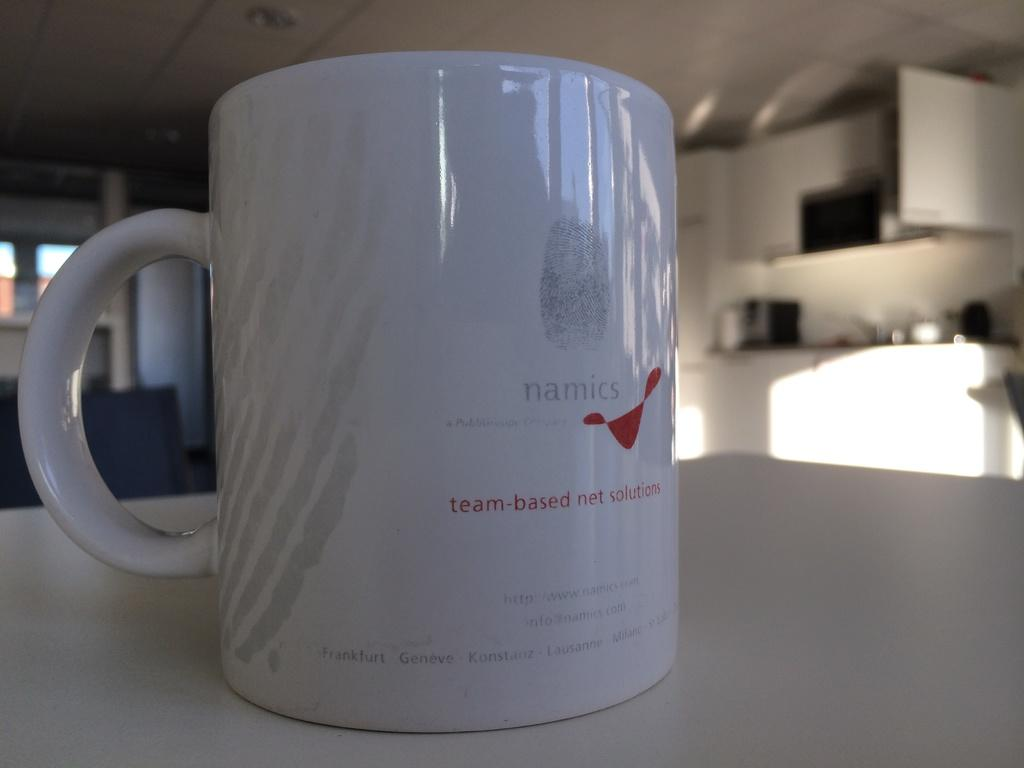<image>
Write a terse but informative summary of the picture. A mug branded with a company called Namics is sitting on a table. 